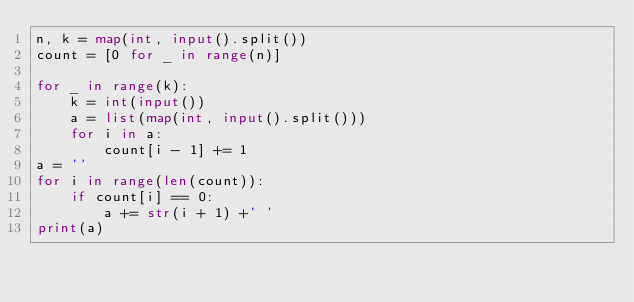Convert code to text. <code><loc_0><loc_0><loc_500><loc_500><_Python_>n, k = map(int, input().split())
count = [0 for _ in range(n)]

for _ in range(k):
    k = int(input())
    a = list(map(int, input().split()))
    for i in a:
        count[i - 1] += 1
a = ''
for i in range(len(count)):
    if count[i] == 0:
        a += str(i + 1) +' '
print(a)</code> 